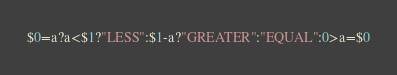<code> <loc_0><loc_0><loc_500><loc_500><_Awk_>$0=a?a<$1?"LESS":$1-a?"GREATER":"EQUAL":0>a=$0</code> 